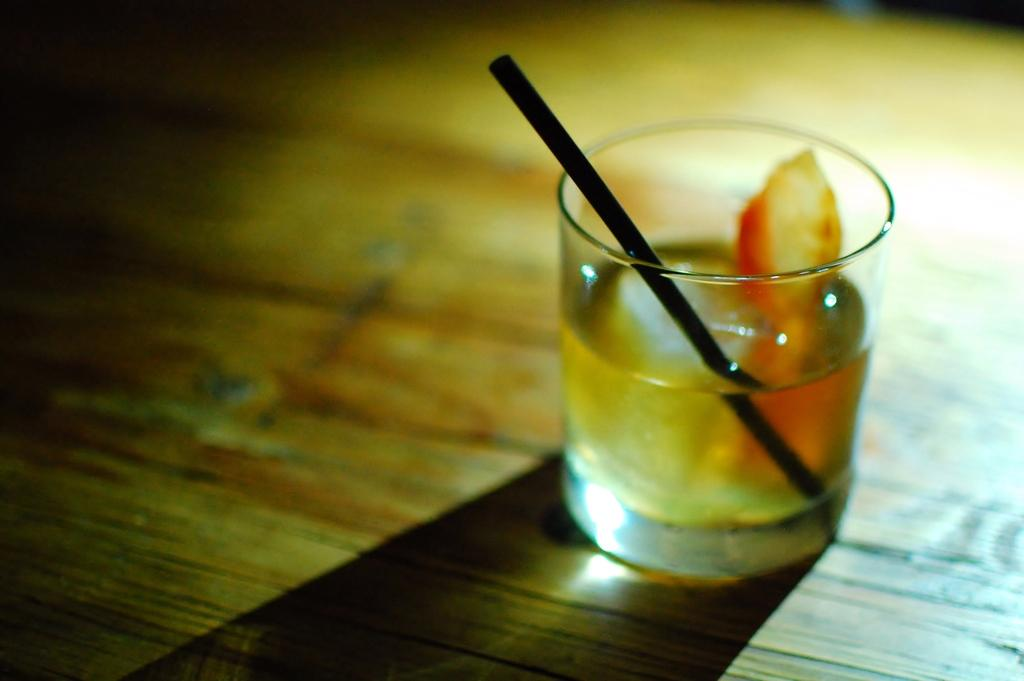What is in the glass that is visible in the image? The glass contains a straw and liquid. Where is the glass located in the image? The glass and its contents are on a table. What type of basket is hanging from the branch in the image? There is no basket or branch present in the image; it only features a glass with a straw and liquid on a table. 